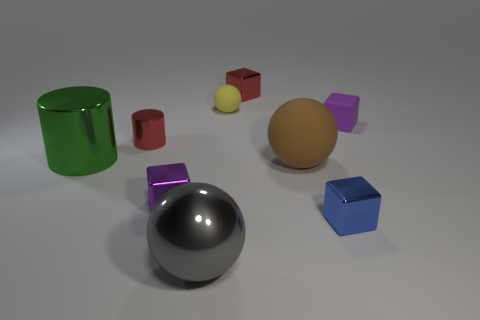Is the number of rubber blocks to the left of the red metallic cylinder greater than the number of tiny purple metallic objects that are in front of the blue thing?
Your answer should be compact. No. Are there any rubber blocks that have the same size as the purple shiny object?
Ensure brevity in your answer.  Yes. What size is the purple cube that is right of the small red object that is right of the tiny purple object that is to the left of the brown matte sphere?
Give a very brief answer. Small. What color is the big metal ball?
Your answer should be compact. Gray. Are there more tiny metal blocks that are in front of the big green metal cylinder than tiny red metallic blocks?
Your response must be concise. Yes. There is a red cylinder; how many green metal cylinders are on the right side of it?
Offer a very short reply. 0. There is a thing that is the same color as the tiny matte cube; what shape is it?
Ensure brevity in your answer.  Cube. Are there any big metal objects that are in front of the large sphere that is right of the thing that is in front of the tiny blue block?
Offer a very short reply. Yes. Do the green metal thing and the purple metal thing have the same size?
Your answer should be compact. No. Are there the same number of red objects that are in front of the large green shiny cylinder and rubber cubes that are behind the blue object?
Your response must be concise. No. 